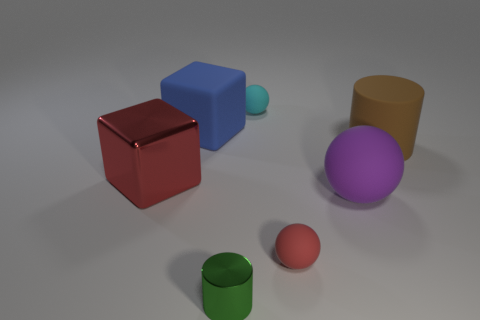How many small green metallic cylinders are left of the small ball left of the small matte object that is right of the tiny cyan matte ball?
Make the answer very short. 1. There is a red object that is to the left of the metal object that is in front of the big object that is to the left of the blue matte cube; what is its shape?
Your answer should be very brief. Cube. What number of other objects are the same color as the tiny metal thing?
Your answer should be very brief. 0. There is a big brown thing that is behind the red thing on the left side of the tiny red thing; what shape is it?
Ensure brevity in your answer.  Cylinder. There is a large sphere; how many rubber spheres are in front of it?
Offer a terse response. 1. Is there a small green cylinder that has the same material as the blue object?
Provide a succinct answer. No. There is a purple sphere that is the same size as the shiny cube; what is it made of?
Your response must be concise. Rubber. How big is the thing that is both on the left side of the tiny cylinder and in front of the large blue matte object?
Give a very brief answer. Large. There is a large object that is in front of the brown matte thing and on the right side of the small red sphere; what is its color?
Ensure brevity in your answer.  Purple. Is the number of blue matte things that are in front of the large matte cylinder less than the number of shiny things that are behind the big blue thing?
Offer a terse response. No. 